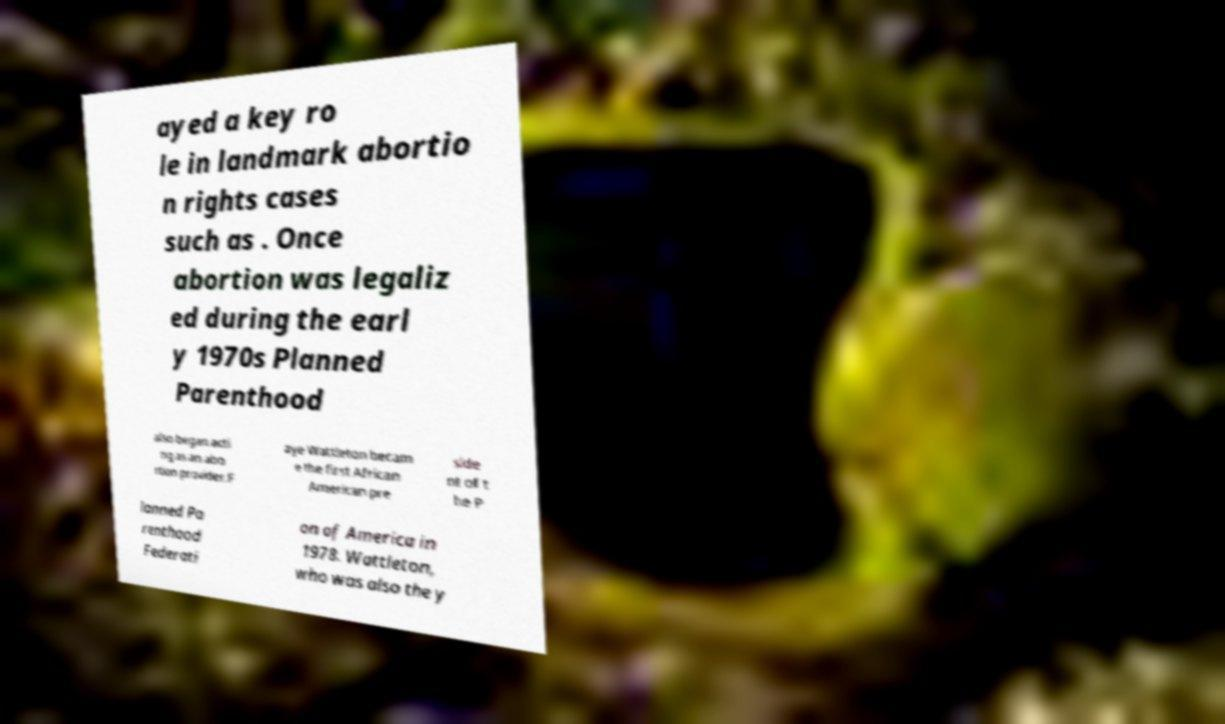I need the written content from this picture converted into text. Can you do that? ayed a key ro le in landmark abortio n rights cases such as . Once abortion was legaliz ed during the earl y 1970s Planned Parenthood also began acti ng as an abo rtion provider.F aye Wattleton becam e the first African American pre side nt of t he P lanned Pa renthood Federati on of America in 1978. Wattleton, who was also the y 